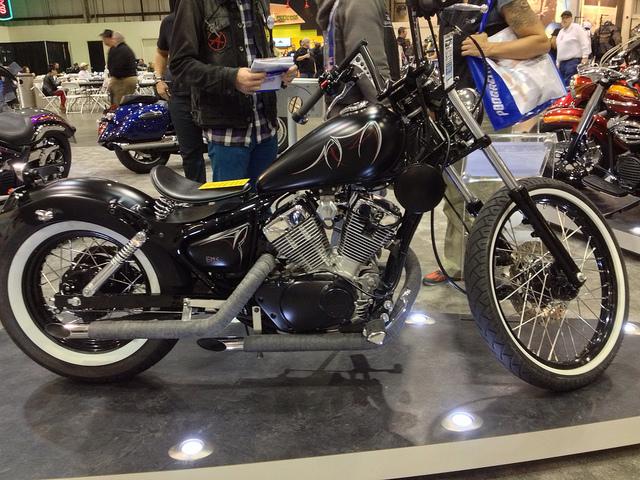What kind of event is taking place?
Short answer required. Motorcycle show. What brand is on the blue and white bag?
Keep it brief. Progressive. What type of bike is being showcased in this photo?
Short answer required. Motorcycle. 